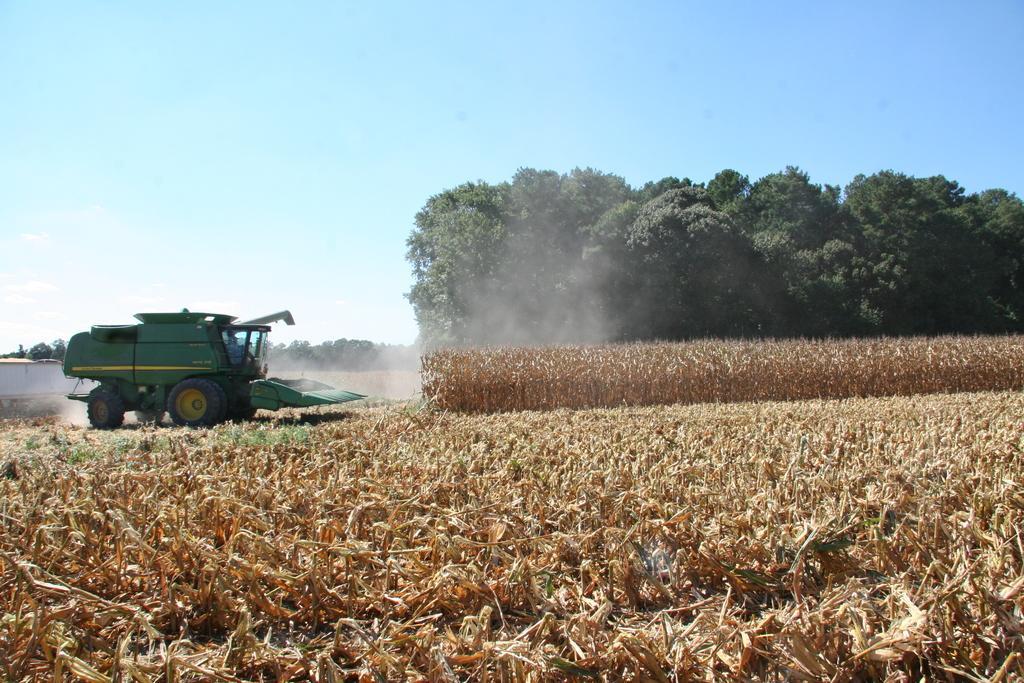Can you describe this image briefly? In this image at the bottom there are some plants, and on the left side of the image there is one vehicle. And in the background there are trees and one house, at the top there is sky. 